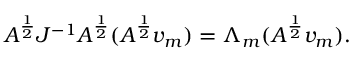<formula> <loc_0><loc_0><loc_500><loc_500>A ^ { \frac { 1 } { 2 } } J ^ { - 1 } A ^ { \frac { 1 } { 2 } } ( A ^ { \frac { 1 } { 2 } } v _ { m } ) = \Lambda _ { m } ( A ^ { \frac { 1 } { 2 } } v _ { m } ) .</formula> 